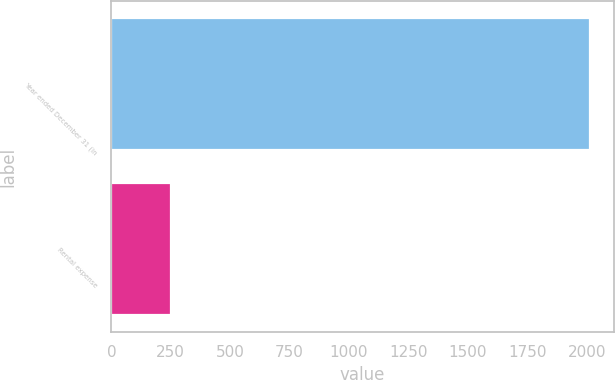Convert chart to OTSL. <chart><loc_0><loc_0><loc_500><loc_500><bar_chart><fcel>Year ended December 31 (in<fcel>Rental expense<nl><fcel>2013<fcel>250<nl></chart> 